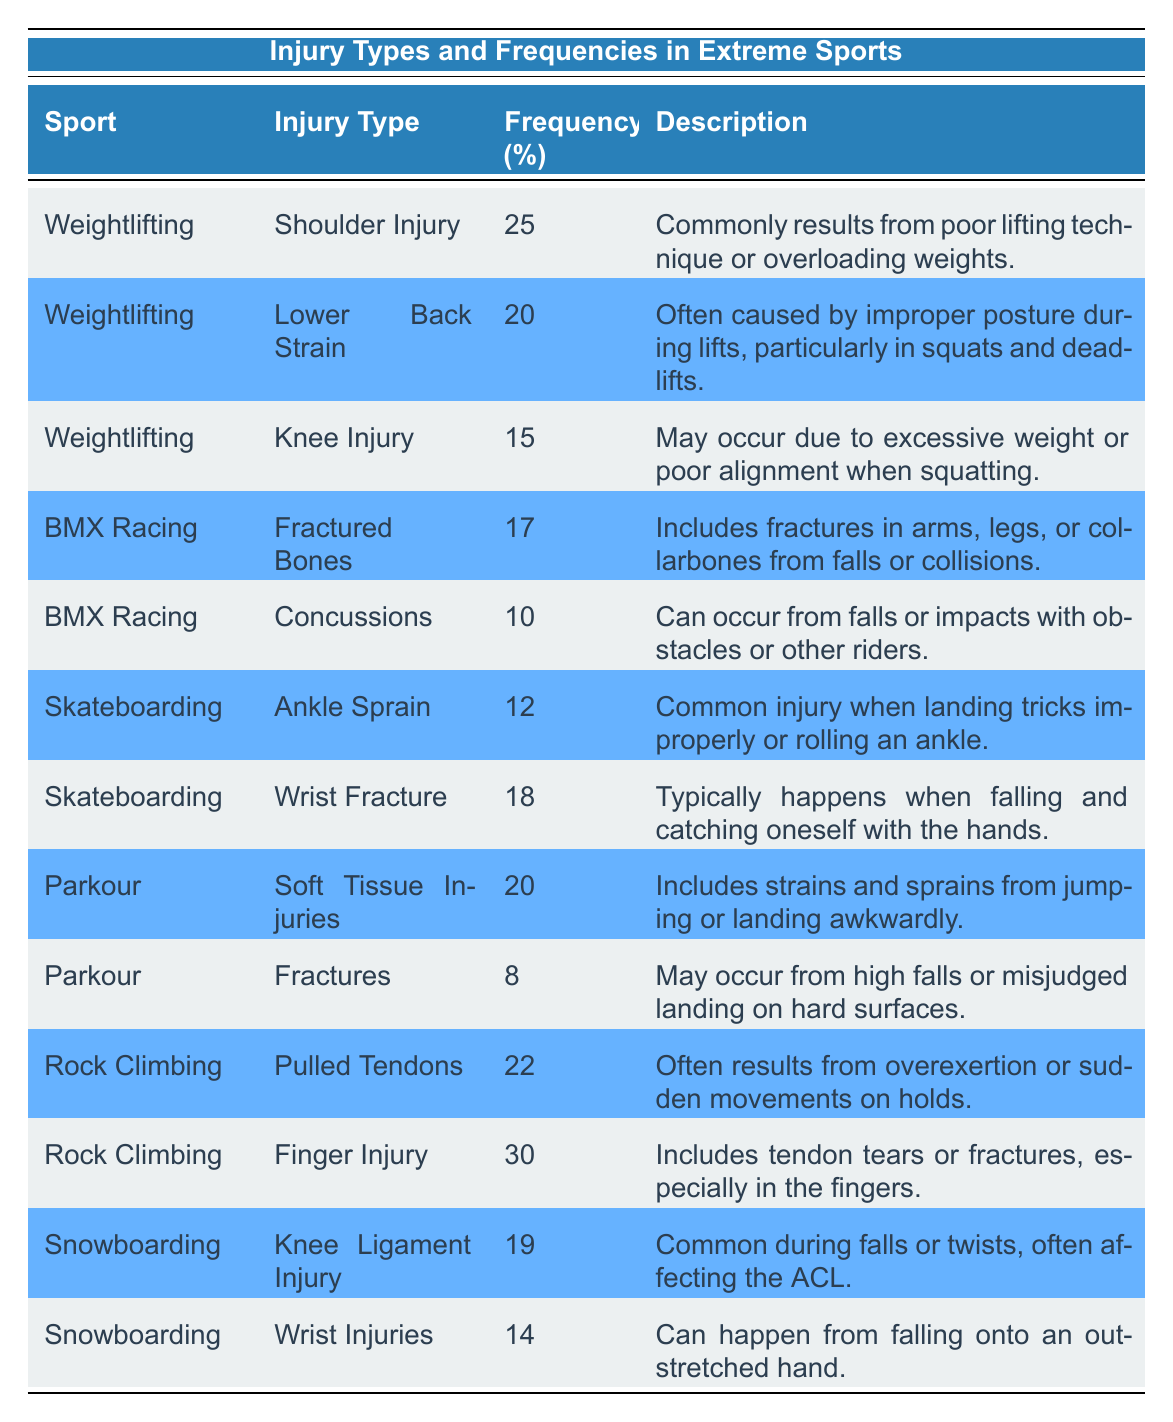What is the most frequently occurring injury type in weightlifting? The table shows three injury types for weightlifting. Among them, the "Shoulder Injury" has a frequency of 25, "Lower Back Strain" has 20, and "Knee Injury" has 15. Therefore, the most frequently occurring injury type is the one with the highest frequency, which is the "Shoulder Injury".
Answer: Shoulder Injury How many total different injury types are listed for BMX Racing? Looking at the BMX Racing section in the table, there are two injury types: "Fractured Bones" and "Concussions". Therefore, the total different injury types listed for BMX Racing is simply the count of these entries.
Answer: 2 What is the average frequency of injuries in skateboarding? The table lists two injury types for skateboarding: "Ankle Sprain" with a frequency of 12 and "Wrist Fracture" with a frequency of 18. To find the average, we add the frequencies (12 + 18 = 30) and then divide by the number of injury types (30 / 2 = 15).
Answer: 15 Is the frequency of knee injuries in snowboarding greater than that in weightlifting? In the table, the frequency for "Knee Ligament Injury" in snowboarding is 19. For weightlifting, the "Knee Injury" frequency is 15. To answer the question, we compare the two values and find that 19 is greater than 15, which confirms that the frequency in snowboarding is higher.
Answer: Yes What is the difference in frequency between finger injuries in rock climbing and wrist injuries in snowboarding? The frequency for "Finger Injury" in rock climbing is 30 and for "Wrist Injuries" in snowboarding is 14. The difference is found by subtracting the wrist injuries from the finger injuries (30 - 14 = 16). This involves a simple subtraction of the two frequencies.
Answer: 16 Which sport has a higher occurrence of soft tissue injuries, parkour or weightlifting? In the table, the frequency for "Soft Tissue Injuries" in parkour is 20, while weightlifting does not list any soft tissue injuries. To determine which sport has a higher occurrence, we compare the available frequency for parkour to the non-existent frequency for weightlifting. Since 20 is greater than 0, parkour has a higher occurrence of soft tissue injuries.
Answer: Parkour How many injuries in total are recorded for rock climbing? The table lists two injuries for rock climbing: "Pulled Tendons" (22) and "Finger Injury" (30). To calculate the total injuries, we sum these frequencies (22 + 30 = 52). This calculation gives us the total number of injuries recorded for the sport.
Answer: 52 Is the frequency of concussions in BMX racing higher than that of knee injuries in weightlifting? The frequency for "Concussions" in BMX Racing is 10, while the "Knee Injury" frequency for weightlifting is 15. We compare the two values to check if 10 is greater than 15, which it is not. Therefore, the frequency of concussions is lower than that of knee injuries.
Answer: No 